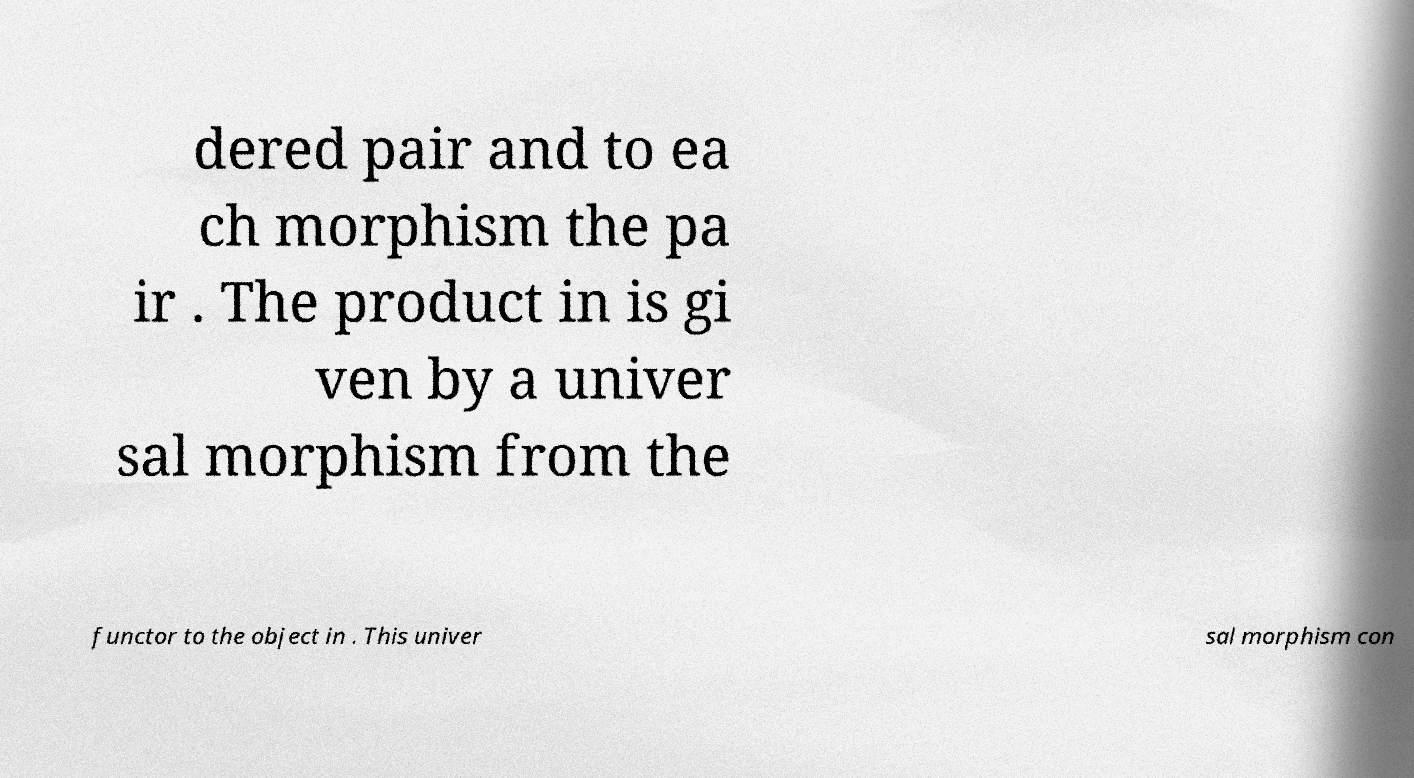Please identify and transcribe the text found in this image. dered pair and to ea ch morphism the pa ir . The product in is gi ven by a univer sal morphism from the functor to the object in . This univer sal morphism con 